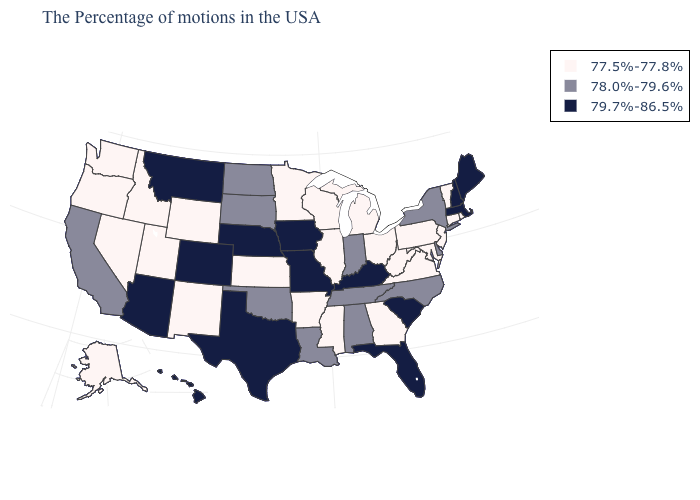Does Kentucky have the lowest value in the USA?
Give a very brief answer. No. What is the value of Michigan?
Short answer required. 77.5%-77.8%. Name the states that have a value in the range 77.5%-77.8%?
Short answer required. Rhode Island, Vermont, Connecticut, New Jersey, Maryland, Pennsylvania, Virginia, West Virginia, Ohio, Georgia, Michigan, Wisconsin, Illinois, Mississippi, Arkansas, Minnesota, Kansas, Wyoming, New Mexico, Utah, Idaho, Nevada, Washington, Oregon, Alaska. Does Wyoming have the same value as Wisconsin?
Give a very brief answer. Yes. Which states have the highest value in the USA?
Keep it brief. Maine, Massachusetts, New Hampshire, South Carolina, Florida, Kentucky, Missouri, Iowa, Nebraska, Texas, Colorado, Montana, Arizona, Hawaii. Which states have the lowest value in the Northeast?
Give a very brief answer. Rhode Island, Vermont, Connecticut, New Jersey, Pennsylvania. Among the states that border Illinois , which have the highest value?
Give a very brief answer. Kentucky, Missouri, Iowa. What is the value of Delaware?
Concise answer only. 78.0%-79.6%. Among the states that border Kentucky , which have the highest value?
Short answer required. Missouri. Which states have the highest value in the USA?
Be succinct. Maine, Massachusetts, New Hampshire, South Carolina, Florida, Kentucky, Missouri, Iowa, Nebraska, Texas, Colorado, Montana, Arizona, Hawaii. What is the highest value in the USA?
Concise answer only. 79.7%-86.5%. What is the value of Maine?
Give a very brief answer. 79.7%-86.5%. What is the highest value in the USA?
Write a very short answer. 79.7%-86.5%. What is the value of Minnesota?
Answer briefly. 77.5%-77.8%. Does Ohio have the same value as Minnesota?
Keep it brief. Yes. 